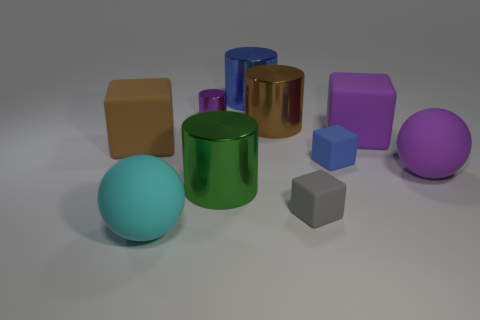There is a tiny object that is left of the green cylinder; is it the same shape as the large metal thing left of the big blue object? Yes, the tiny object to the left of the green cylinder has the same basic shape as the larger metal object to the left of the big blue sphere. They are both shaped like cubes. 